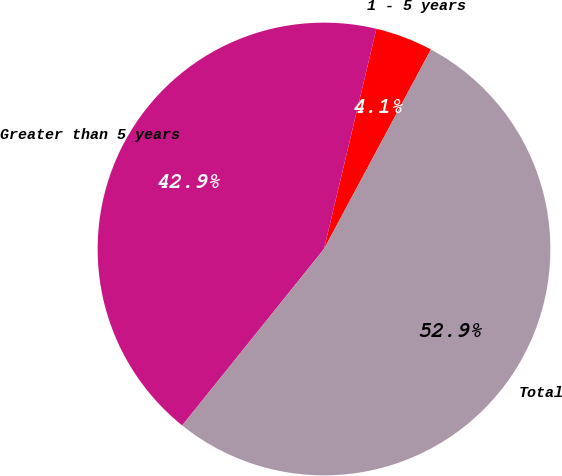Convert chart. <chart><loc_0><loc_0><loc_500><loc_500><pie_chart><fcel>1 - 5 years<fcel>Greater than 5 years<fcel>Total<nl><fcel>4.11%<fcel>42.94%<fcel>52.94%<nl></chart> 